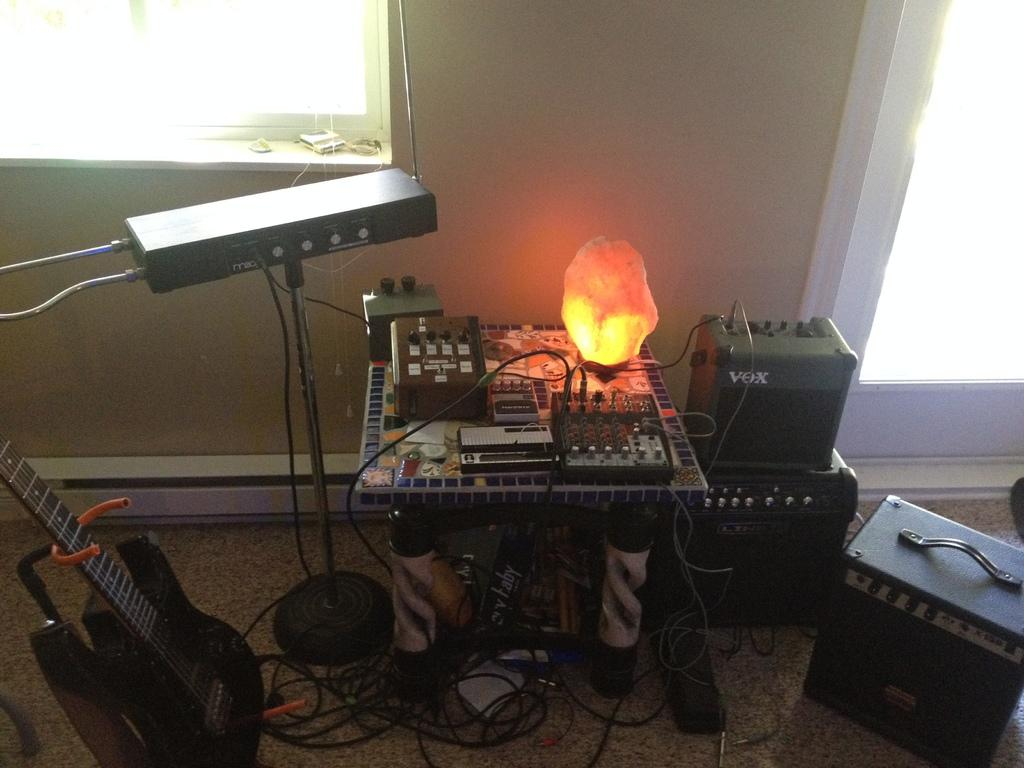What musical instrument is placed on the ground in the image? There is a guitar placed on the ground in the image. What other items related to music can be seen around the guitar? There are music equipment around the guitar. What is in the center of the image? There is a table in the center of the image. What is on the table? A light is on the table. What can be seen in the background of the image? There is a window visible in the background of the image. What type of suit is the guitar wearing in the image? The guitar is not wearing a suit, as it is an inanimate object and does not have the ability to wear clothing. 